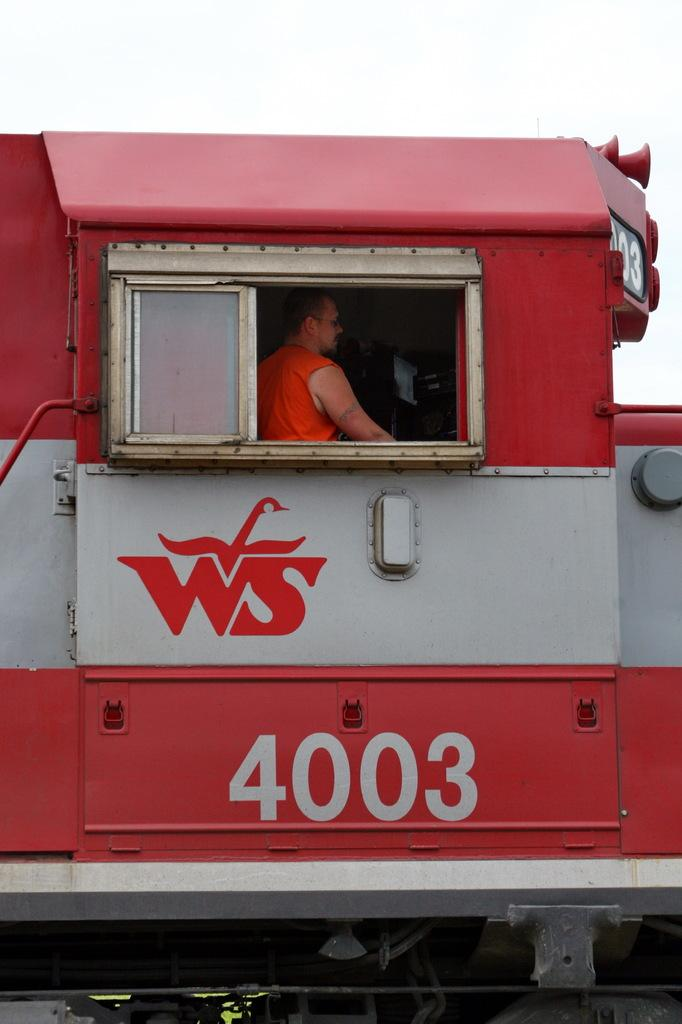What can be seen in the background of the image? The sky is visible in the image. What is the main subject of the image? There is a train in the image. How much of the train is visible? The train is partially visible (truncated). Can you describe the person inside the train? There is a person inside the train, but their appearance or actions cannot be determined from the image. What additional information is present on the train? There is a number and text on the train. What type of boats can be seen sailing in the sky in the image? There are no boats visible in the image, and the sky is not occupied by any water for boats to sail on. 